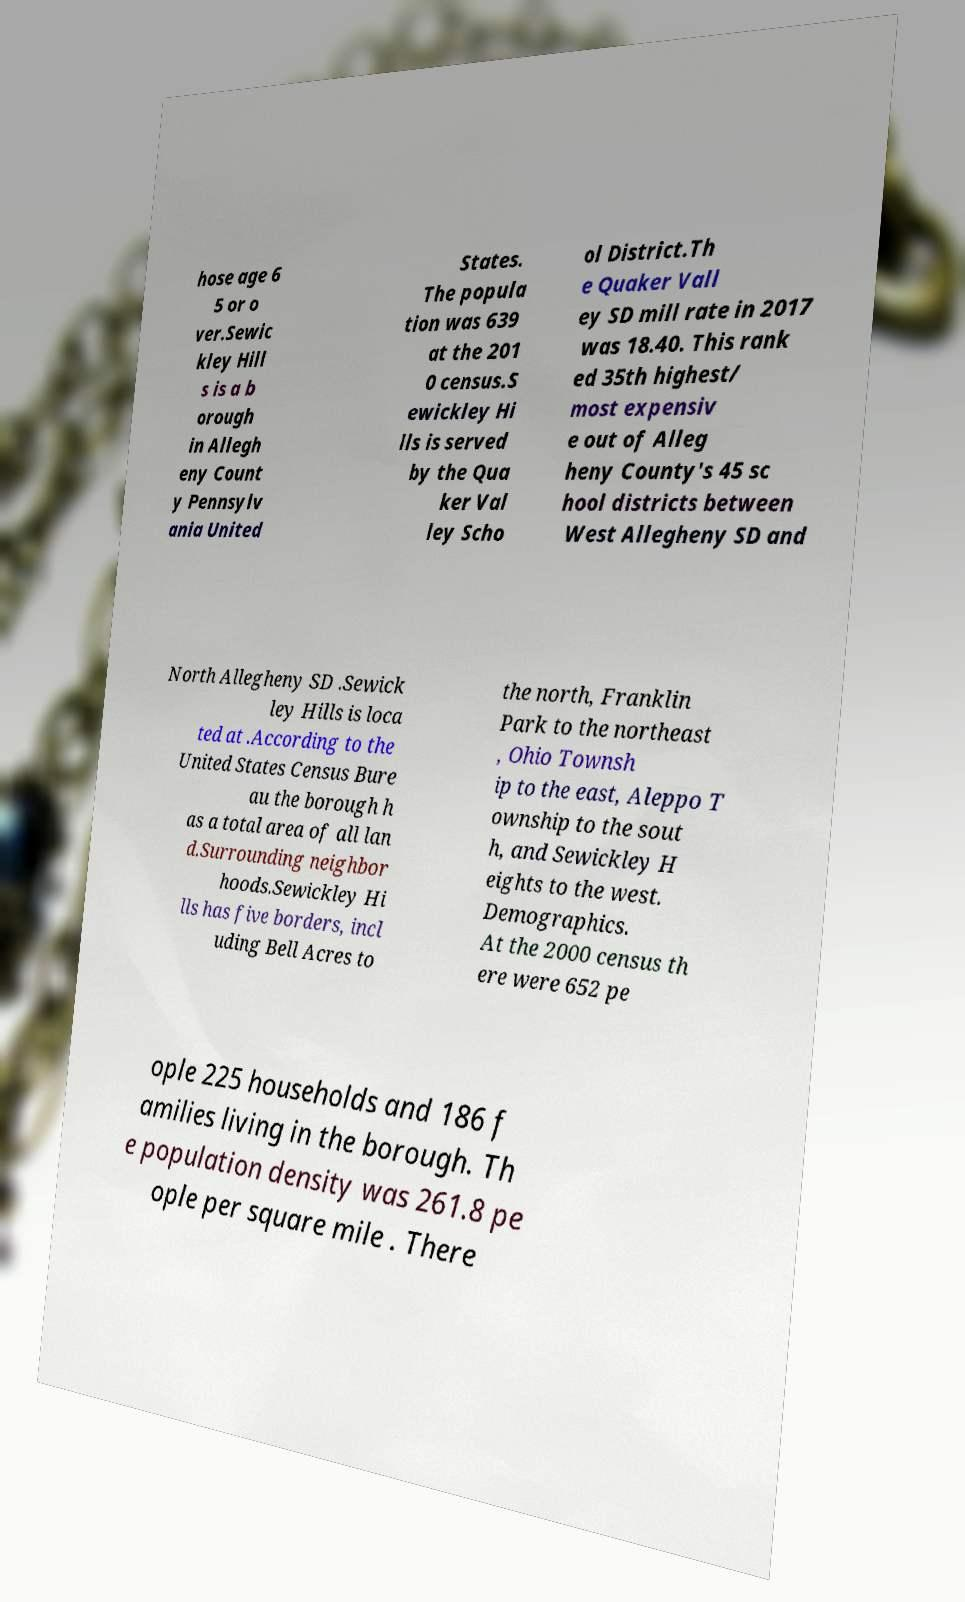Can you accurately transcribe the text from the provided image for me? hose age 6 5 or o ver.Sewic kley Hill s is a b orough in Allegh eny Count y Pennsylv ania United States. The popula tion was 639 at the 201 0 census.S ewickley Hi lls is served by the Qua ker Val ley Scho ol District.Th e Quaker Vall ey SD mill rate in 2017 was 18.40. This rank ed 35th highest/ most expensiv e out of Alleg heny County's 45 sc hool districts between West Allegheny SD and North Allegheny SD .Sewick ley Hills is loca ted at .According to the United States Census Bure au the borough h as a total area of all lan d.Surrounding neighbor hoods.Sewickley Hi lls has five borders, incl uding Bell Acres to the north, Franklin Park to the northeast , Ohio Townsh ip to the east, Aleppo T ownship to the sout h, and Sewickley H eights to the west. Demographics. At the 2000 census th ere were 652 pe ople 225 households and 186 f amilies living in the borough. Th e population density was 261.8 pe ople per square mile . There 